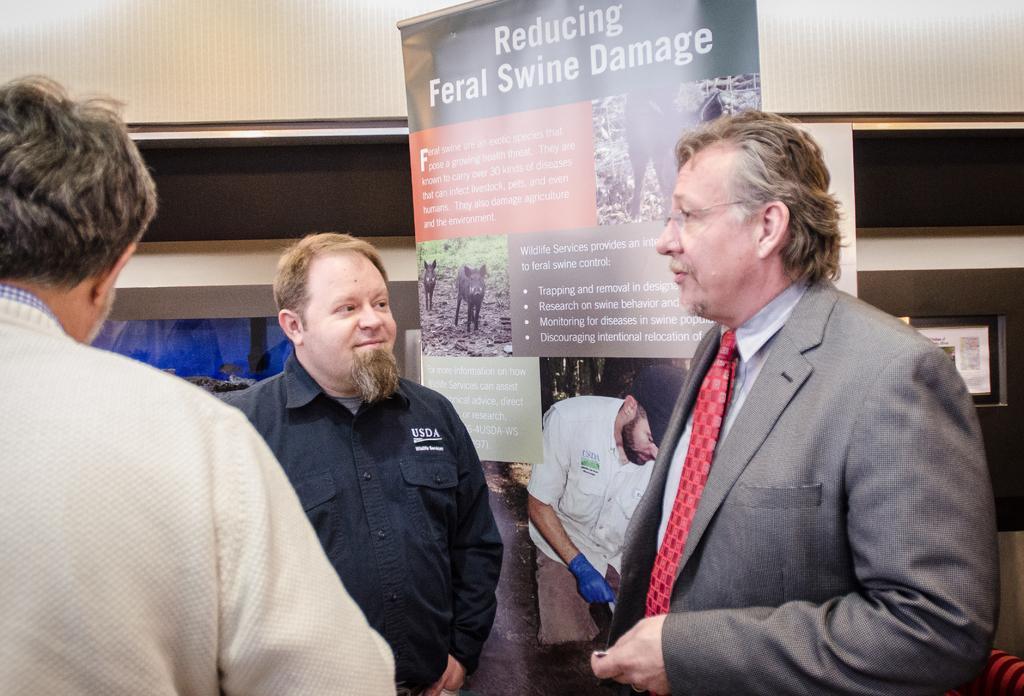Could you give a brief overview of what you see in this image? In the image we can see there are three men standing and wearing clothes. Here we can see the banner, on it there is a text and some pictures and we can see the wall. 